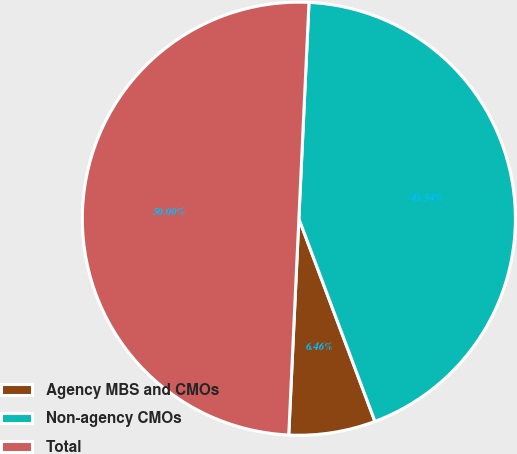Convert chart. <chart><loc_0><loc_0><loc_500><loc_500><pie_chart><fcel>Agency MBS and CMOs<fcel>Non-agency CMOs<fcel>Total<nl><fcel>6.46%<fcel>43.54%<fcel>50.0%<nl></chart> 